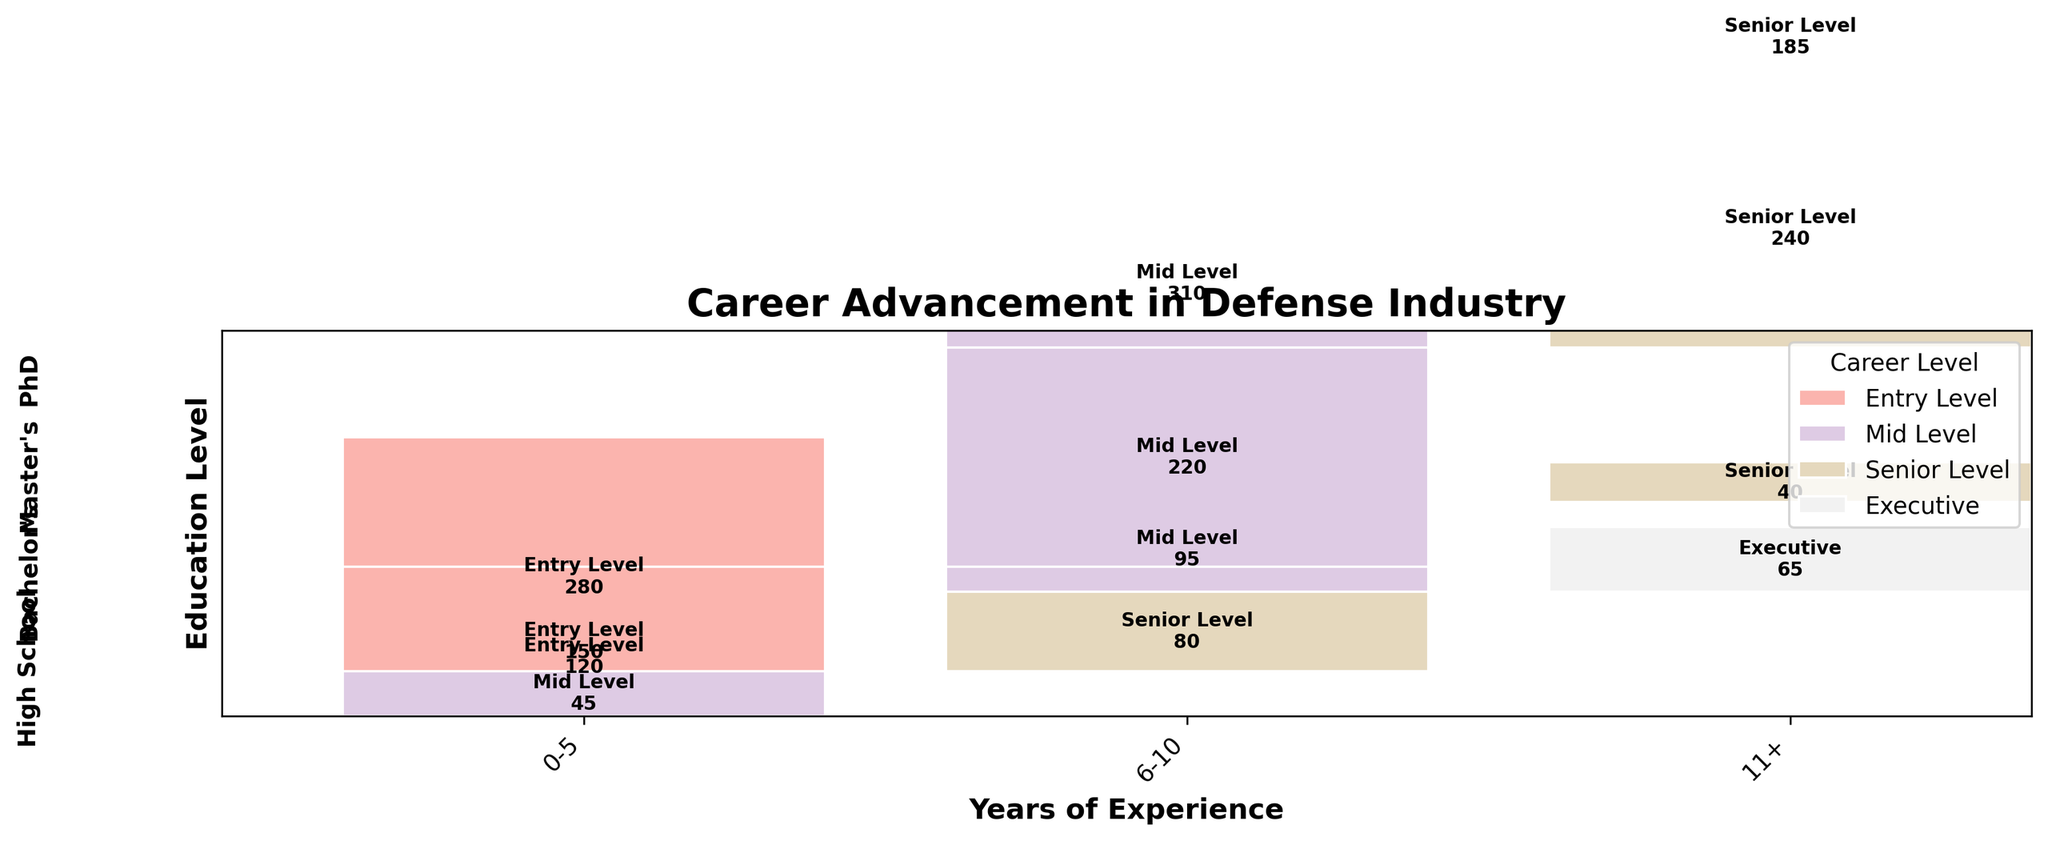What's the title of the figure? The title of the figure is usually displayed at the top of the plot for easy identification.
Answer: Career Advancement in Defense Industry How many levels of education are represented in the plot? By looking at the y-axis labels (education levels), you will notice there are four distinct levels of education displayed.
Answer: Four Which education level has the highest number of entry-level positions for 0-5 years of experience? By viewing the size of the rectangles for entry-level positions in the 0-5 years of experience category, Bachelor's degree has the largest rectangle.
Answer: Bachelor's What is the career level distribution for individuals with a PhD and 11+ years of experience? Locate the PhD section on the y-axis, then check rectangles for 11+ years of experience. The rectangle's label and size indicate the career levels.
Answer: Executive: 65 How does the number of mid-level positions for individuals with 6-10 years of experience compare between a Bachelor's and Master's degree? Find the rectangles representing mid-level positions for 6-10 years of experience for both Bachelor's and Master's degrees. Compare their counts.
Answer: Bachelor's: 310, Master's: 220 What's the total number of career counts for individuals with a Master's degree? Sum the counts of all rectangles associated with a Master's degree regardless of career level or years of experience.
Answer: 610 Is there any career level not represented by individuals with a high school education? Examine all career levels associated with high school education rectangles.
Answer: Executive Which career level is most dominant across all education levels for individuals with 0-5 years of experience? Check all rectangles corresponding to 0-5 years of experience across every education level and determine which career level appears most frequently.
Answer: Entry Level How does the career advancement to senior level differ between individuals with Bachelor's and Master's degrees having 11+ years of experience? Compare the rectangle sizes and counts for senior-level positions between Bachelor's and Master's degrees for those with 11+ years of experience.
Answer: Bachelor's: 185, Master's: 240 